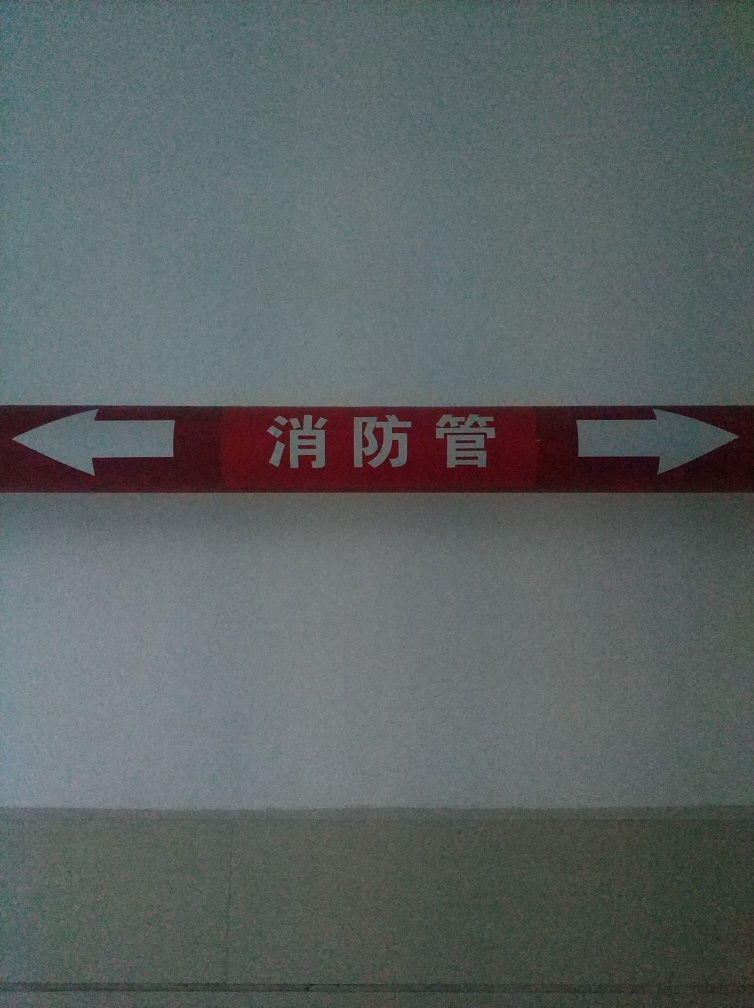This sign seems to have non-English text. Can you tell me what it signifies? While I refrain from reading or interpreting text, this type of sign typically appears in an official or institutional setting. It could indicate the location of services or facilities, such as exits or departments, helping individuals to find their way within the building or area. 